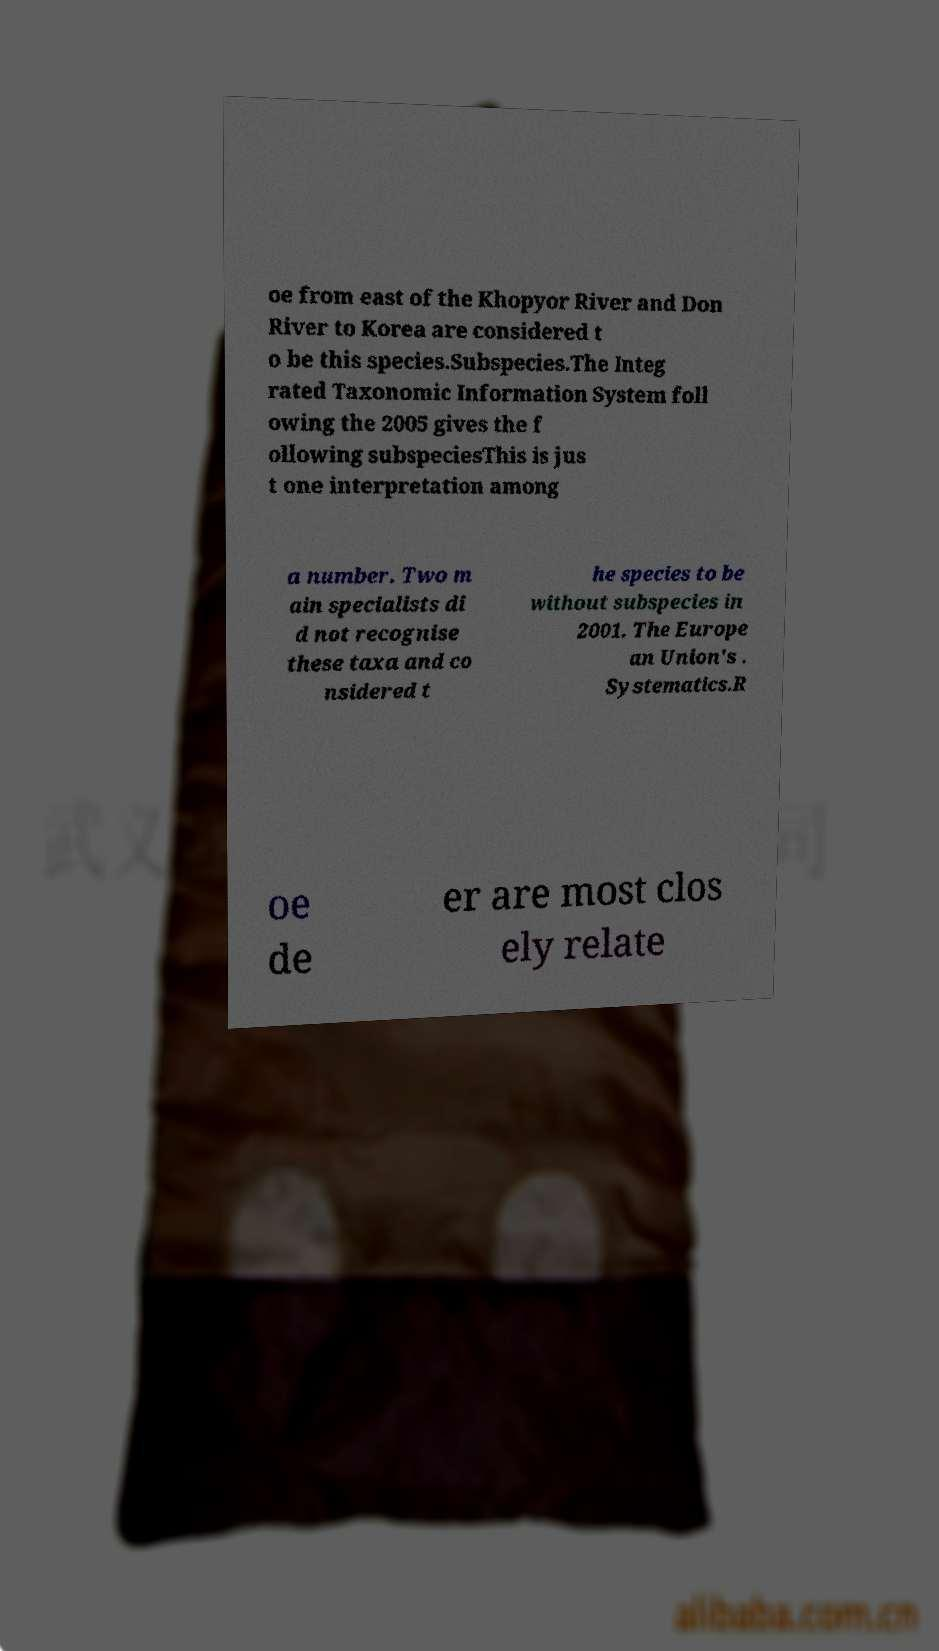Please identify and transcribe the text found in this image. oe from east of the Khopyor River and Don River to Korea are considered t o be this species.Subspecies.The Integ rated Taxonomic Information System foll owing the 2005 gives the f ollowing subspeciesThis is jus t one interpretation among a number. Two m ain specialists di d not recognise these taxa and co nsidered t he species to be without subspecies in 2001. The Europe an Union's . Systematics.R oe de er are most clos ely relate 